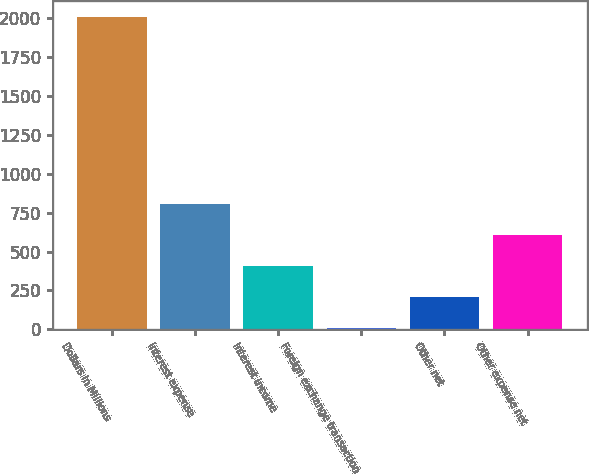Convert chart. <chart><loc_0><loc_0><loc_500><loc_500><bar_chart><fcel>Dollars in Millions<fcel>Interest expense<fcel>Interest income<fcel>Foreign exchange transaction<fcel>Other net<fcel>Other expense net<nl><fcel>2006<fcel>806<fcel>406<fcel>6<fcel>206<fcel>606<nl></chart> 